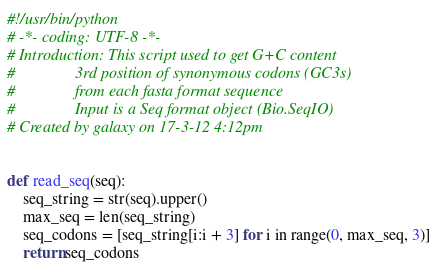Convert code to text. <code><loc_0><loc_0><loc_500><loc_500><_Python_>#!/usr/bin/python
# -*- coding: UTF-8 -*-
# Introduction: This script used to get G+C content
#               3rd position of synonymous codons (GC3s)
#               from each fasta format sequence
#               Input is a Seq format object (Bio.SeqIO)
# Created by galaxy on 17-3-12 4:12pm


def read_seq(seq):
    seq_string = str(seq).upper()
    max_seq = len(seq_string)
    seq_codons = [seq_string[i:i + 3] for i in range(0, max_seq, 3)]
    return seq_codons

</code> 